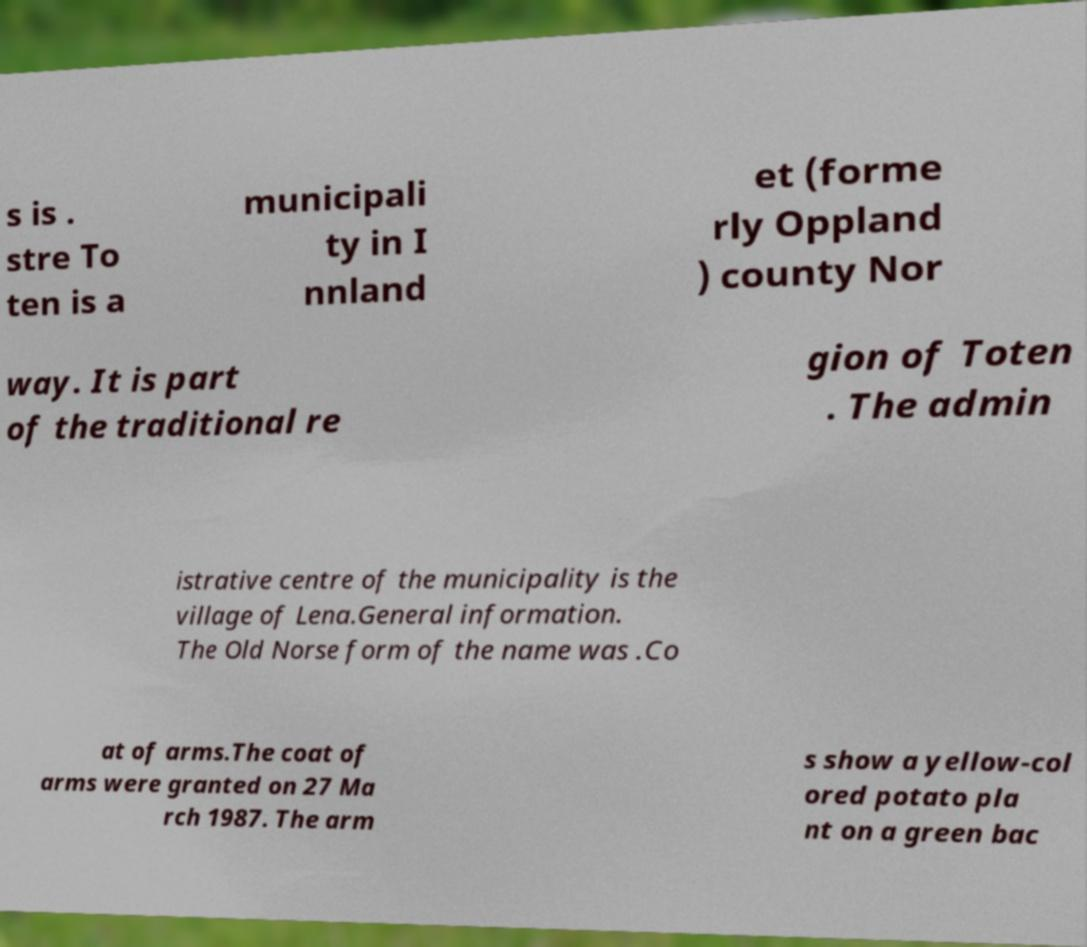There's text embedded in this image that I need extracted. Can you transcribe it verbatim? s is . stre To ten is a municipali ty in I nnland et (forme rly Oppland ) county Nor way. It is part of the traditional re gion of Toten . The admin istrative centre of the municipality is the village of Lena.General information. The Old Norse form of the name was .Co at of arms.The coat of arms were granted on 27 Ma rch 1987. The arm s show a yellow-col ored potato pla nt on a green bac 